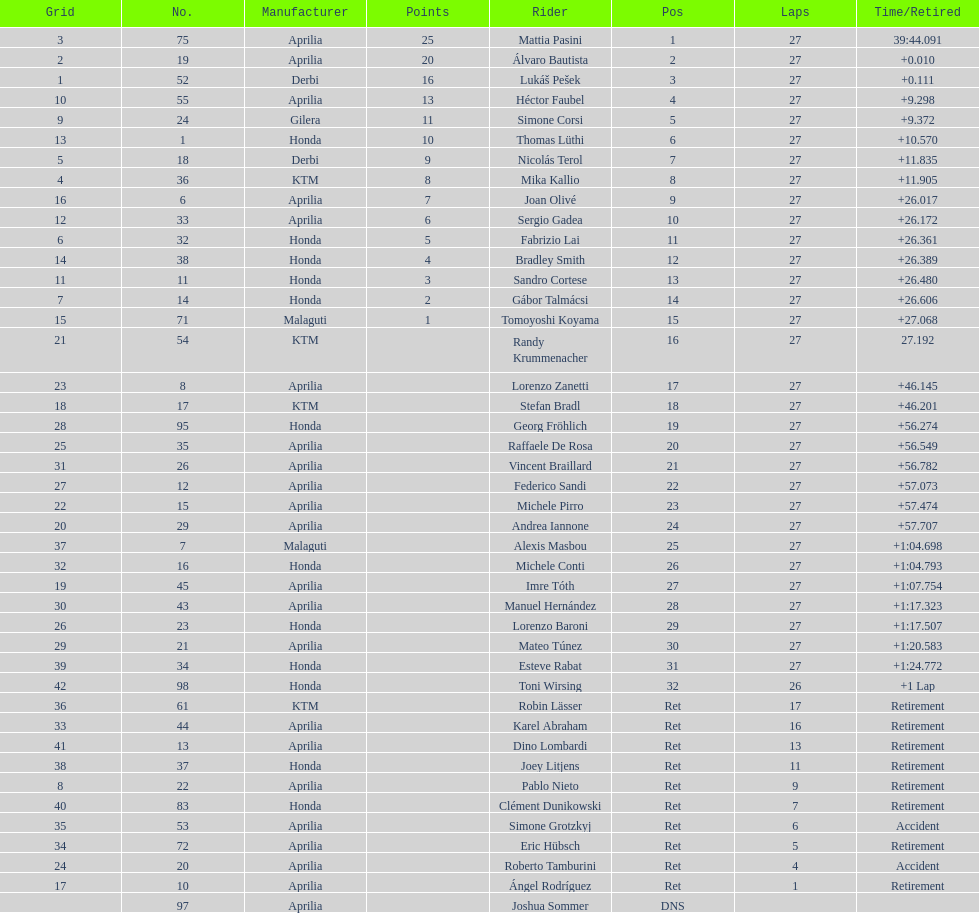Which rider came in first with 25 points? Mattia Pasini. 